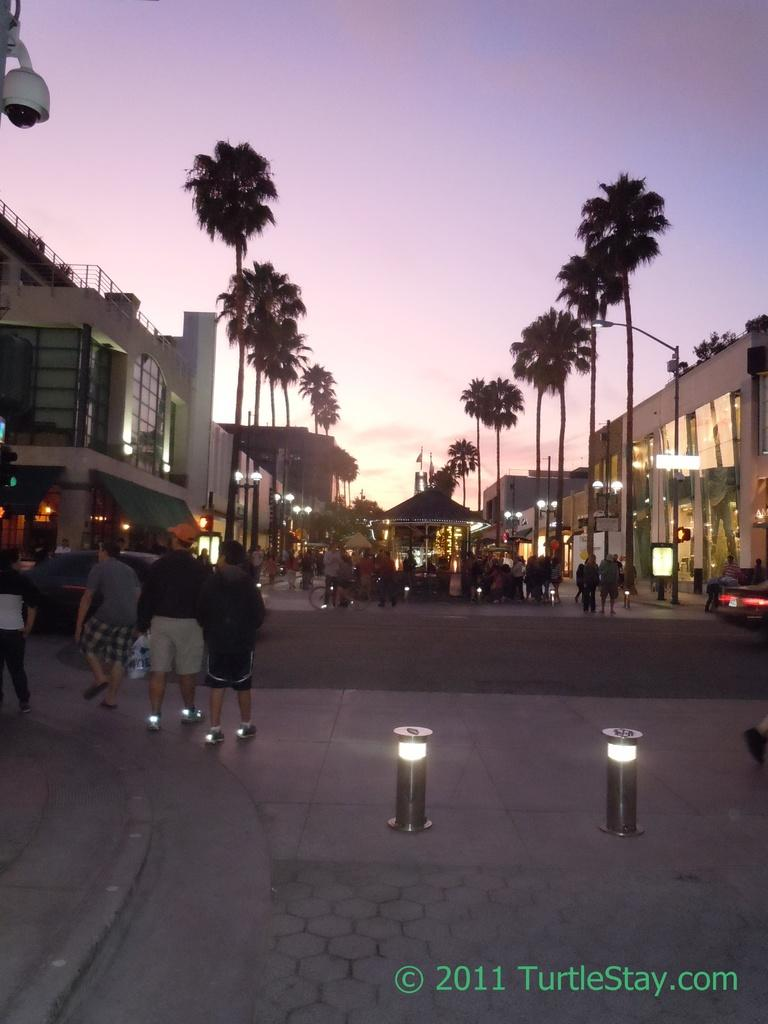What can be seen on the road in the image? There are persons on the road in the image. What else is visible in the image besides the persons on the road? There are lights, trees, poles, buildings, and the sky visible in the image. Can you describe the type of lights visible in the image? The lights in the image could be streetlights or headlights from vehicles. What type of structures can be seen in the image? There are buildings visible in the image. What type of cord is being used to hang the print on the wall in the image? There is no print or cord visible in the image; it only features persons on the road, lights, trees, poles, buildings, and the sky. What type of seed is being planted by the persons on the road in the image? There is no seed or planting activity visible in the image; it only features persons on the road, lights, trees, poles, buildings, and the sky. 